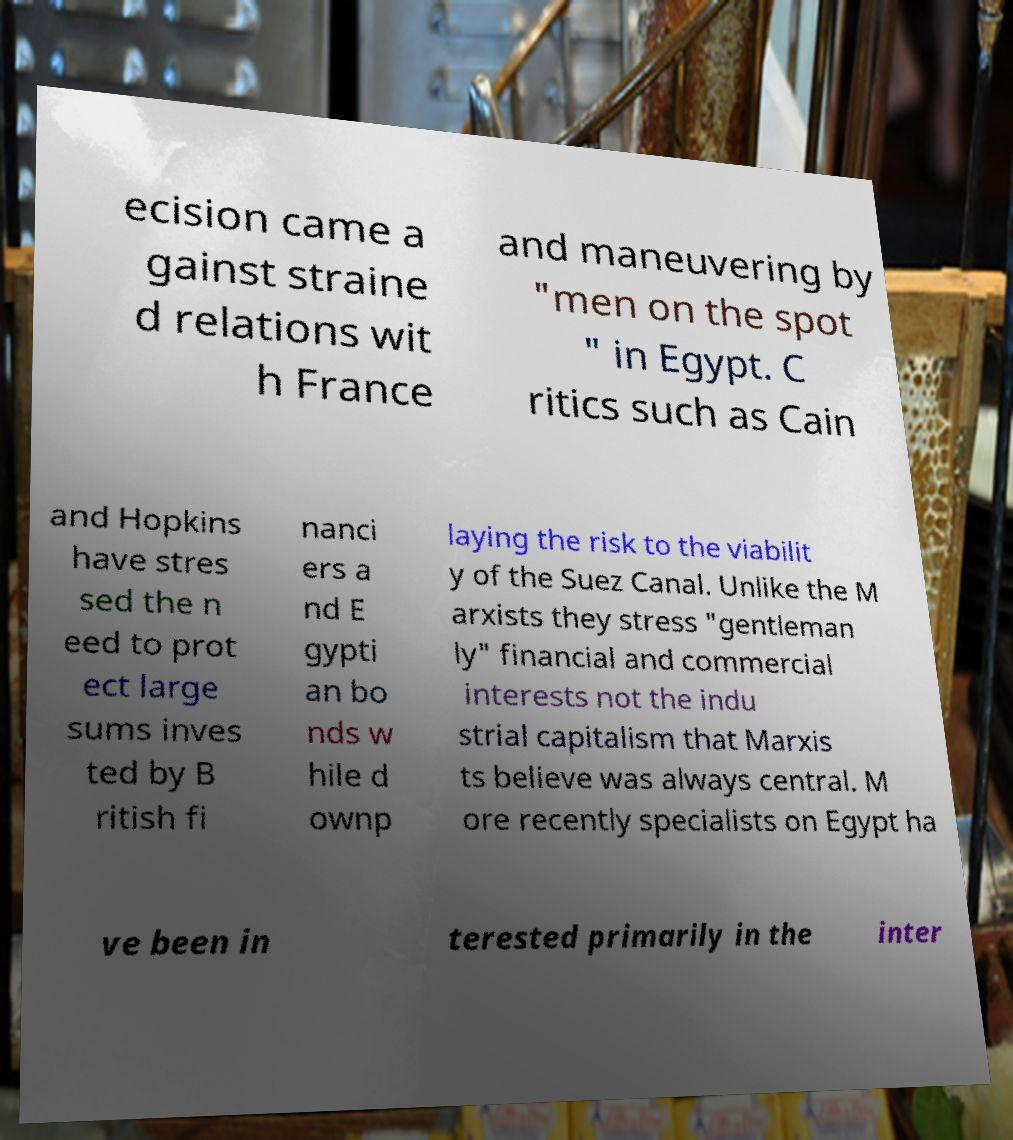Can you accurately transcribe the text from the provided image for me? ecision came a gainst straine d relations wit h France and maneuvering by "men on the spot " in Egypt. C ritics such as Cain and Hopkins have stres sed the n eed to prot ect large sums inves ted by B ritish fi nanci ers a nd E gypti an bo nds w hile d ownp laying the risk to the viabilit y of the Suez Canal. Unlike the M arxists they stress "gentleman ly" financial and commercial interests not the indu strial capitalism that Marxis ts believe was always central. M ore recently specialists on Egypt ha ve been in terested primarily in the inter 